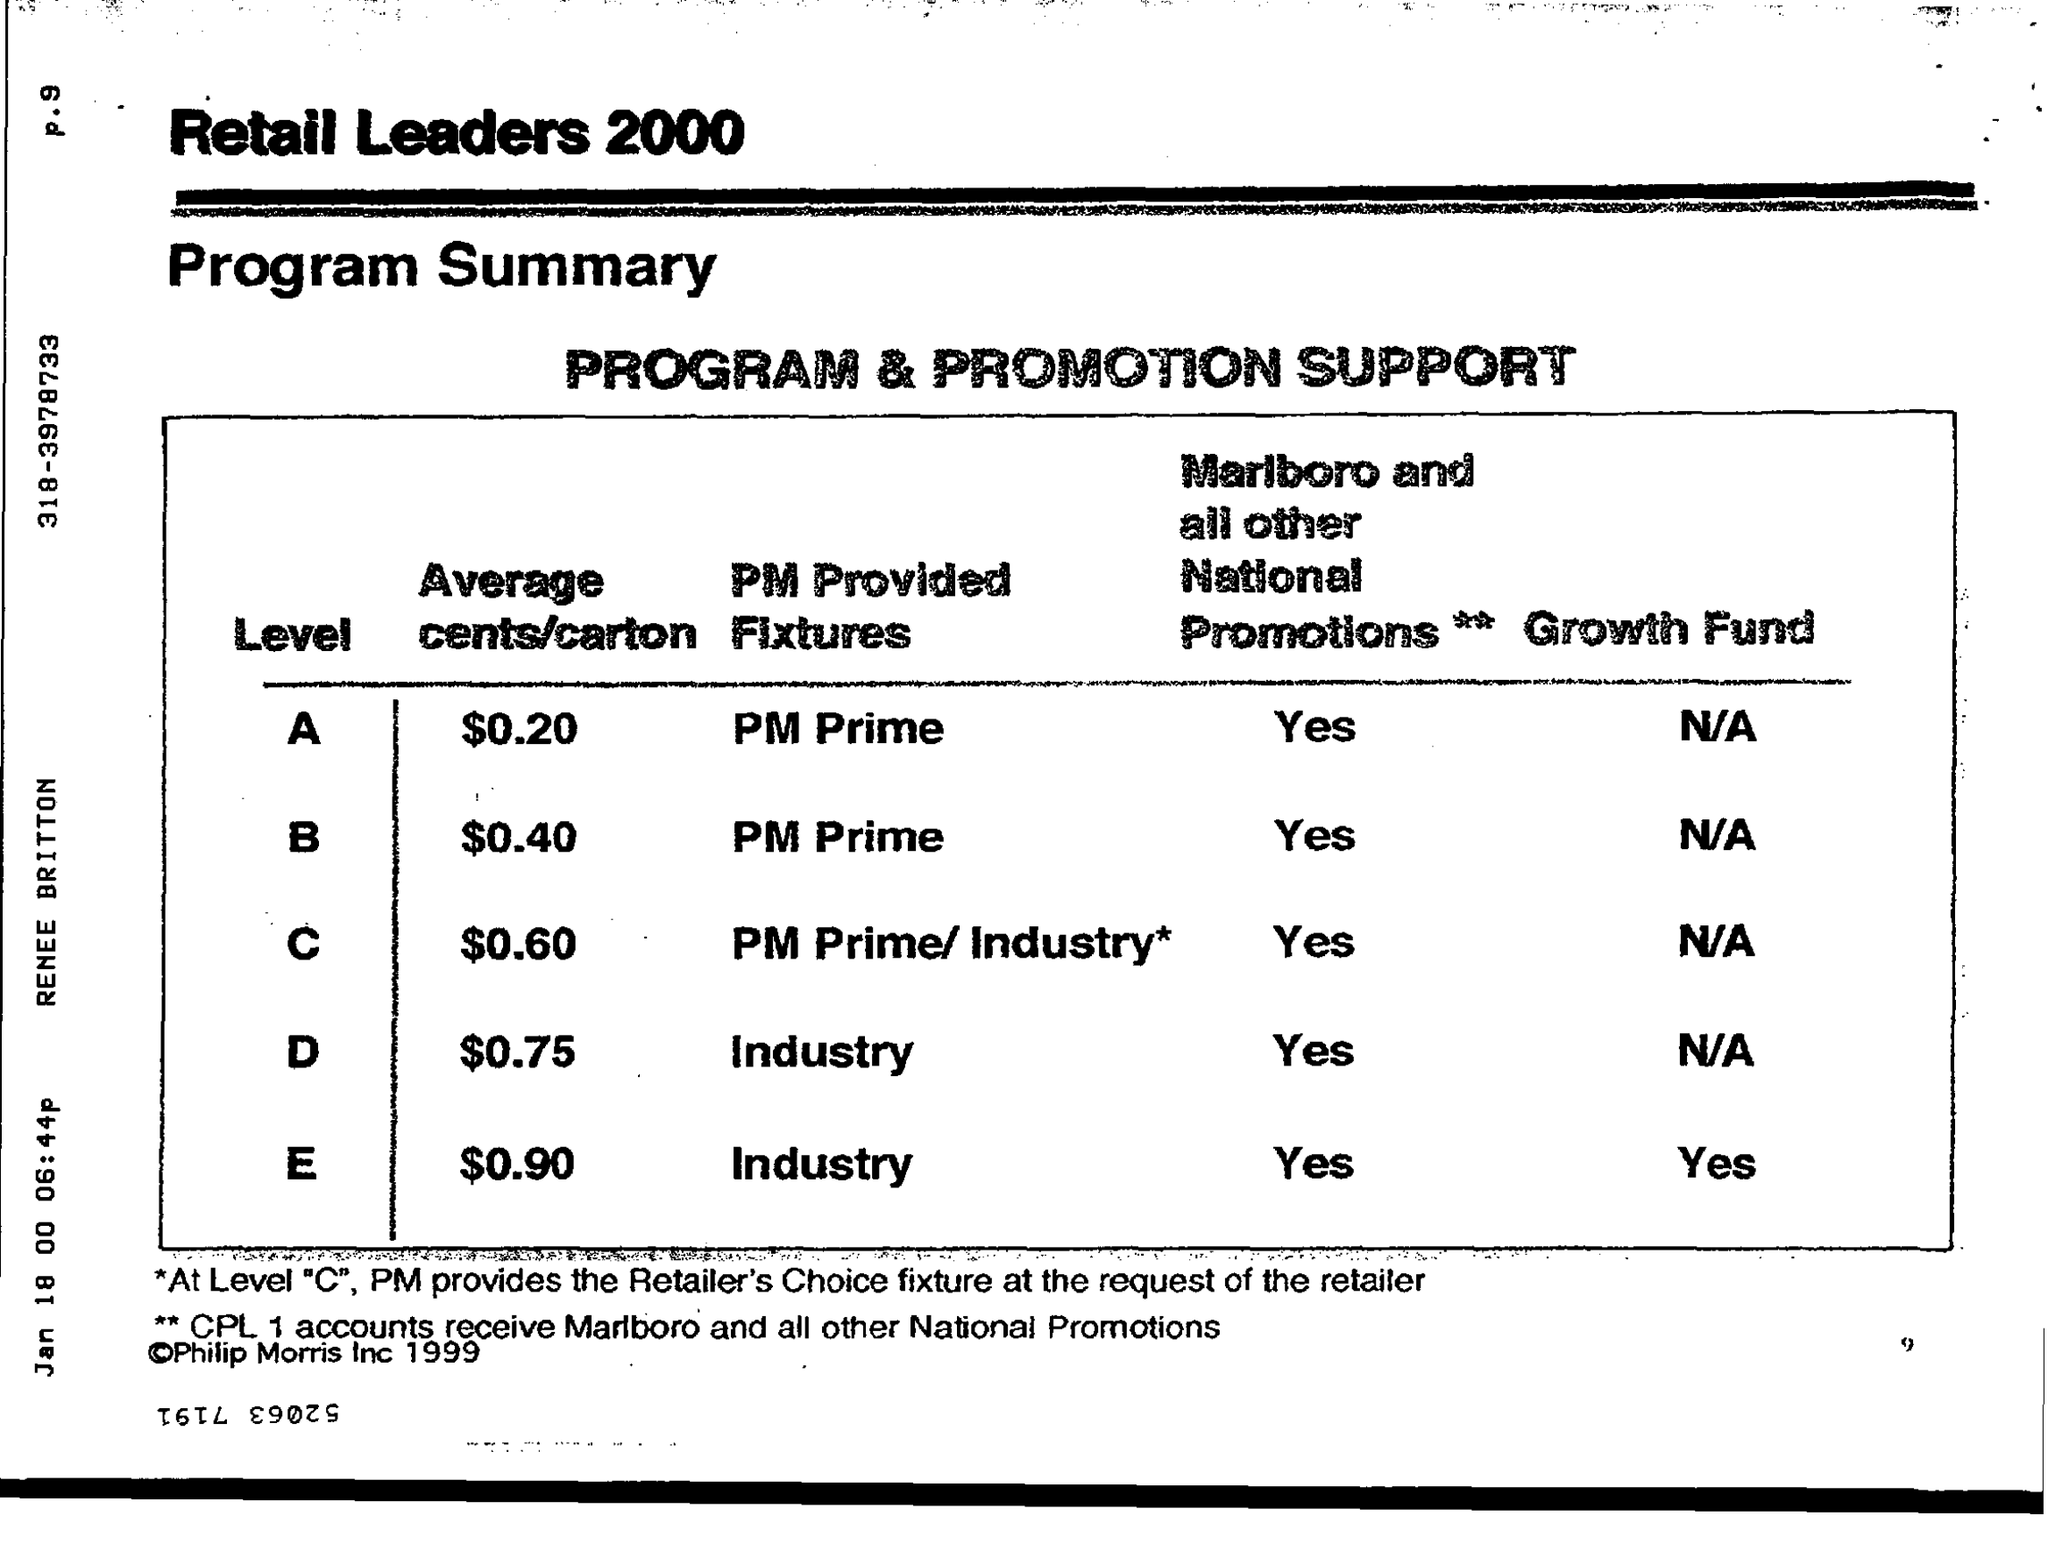Give some essential details in this illustration. The average cost per carton for level A is $0.20. The average cost per carton for level D is $0.75. The status of the growth fund for level E is yes. The PM provided fixtures for level B are PM Prime. 